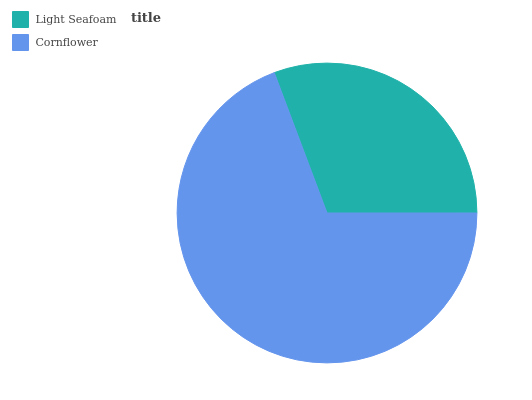Is Light Seafoam the minimum?
Answer yes or no. Yes. Is Cornflower the maximum?
Answer yes or no. Yes. Is Cornflower the minimum?
Answer yes or no. No. Is Cornflower greater than Light Seafoam?
Answer yes or no. Yes. Is Light Seafoam less than Cornflower?
Answer yes or no. Yes. Is Light Seafoam greater than Cornflower?
Answer yes or no. No. Is Cornflower less than Light Seafoam?
Answer yes or no. No. Is Cornflower the high median?
Answer yes or no. Yes. Is Light Seafoam the low median?
Answer yes or no. Yes. Is Light Seafoam the high median?
Answer yes or no. No. Is Cornflower the low median?
Answer yes or no. No. 